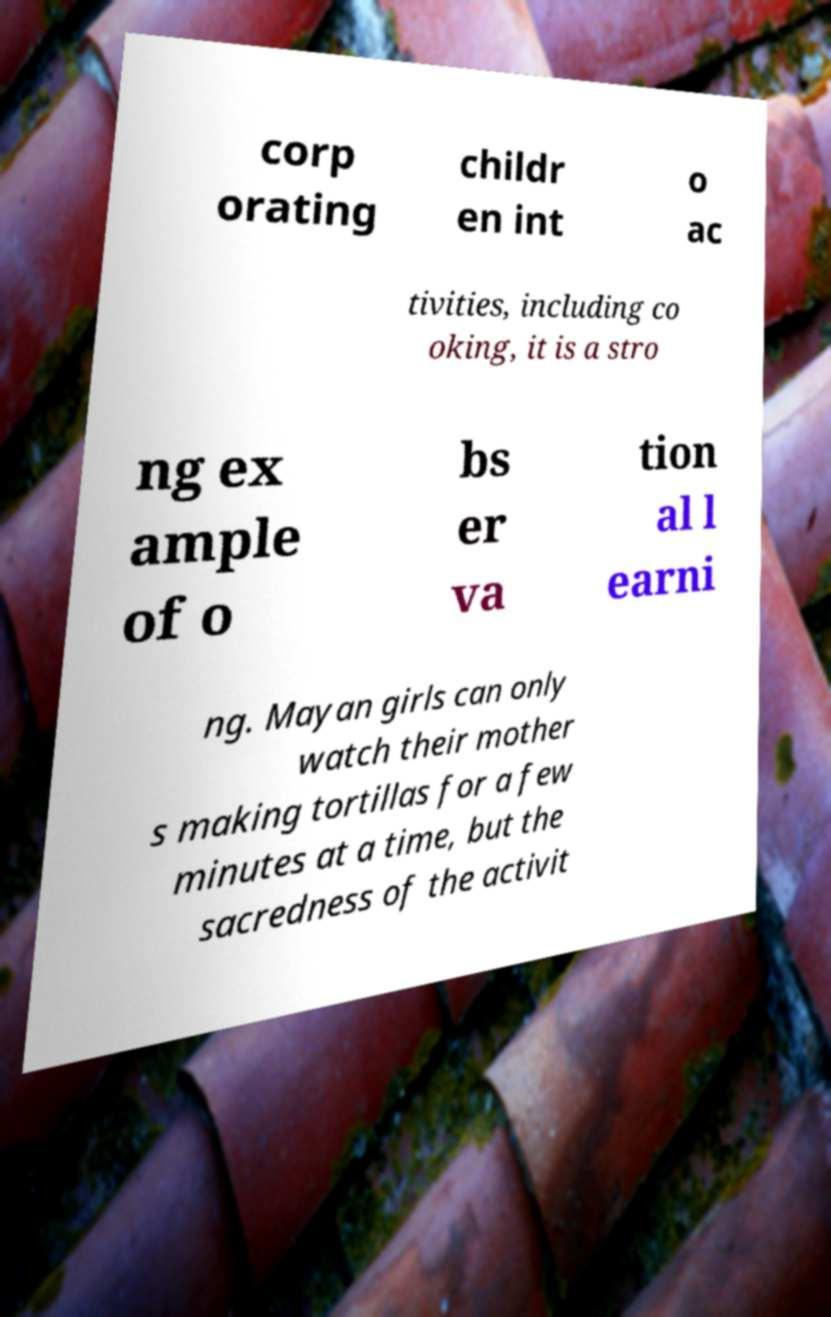There's text embedded in this image that I need extracted. Can you transcribe it verbatim? corp orating childr en int o ac tivities, including co oking, it is a stro ng ex ample of o bs er va tion al l earni ng. Mayan girls can only watch their mother s making tortillas for a few minutes at a time, but the sacredness of the activit 